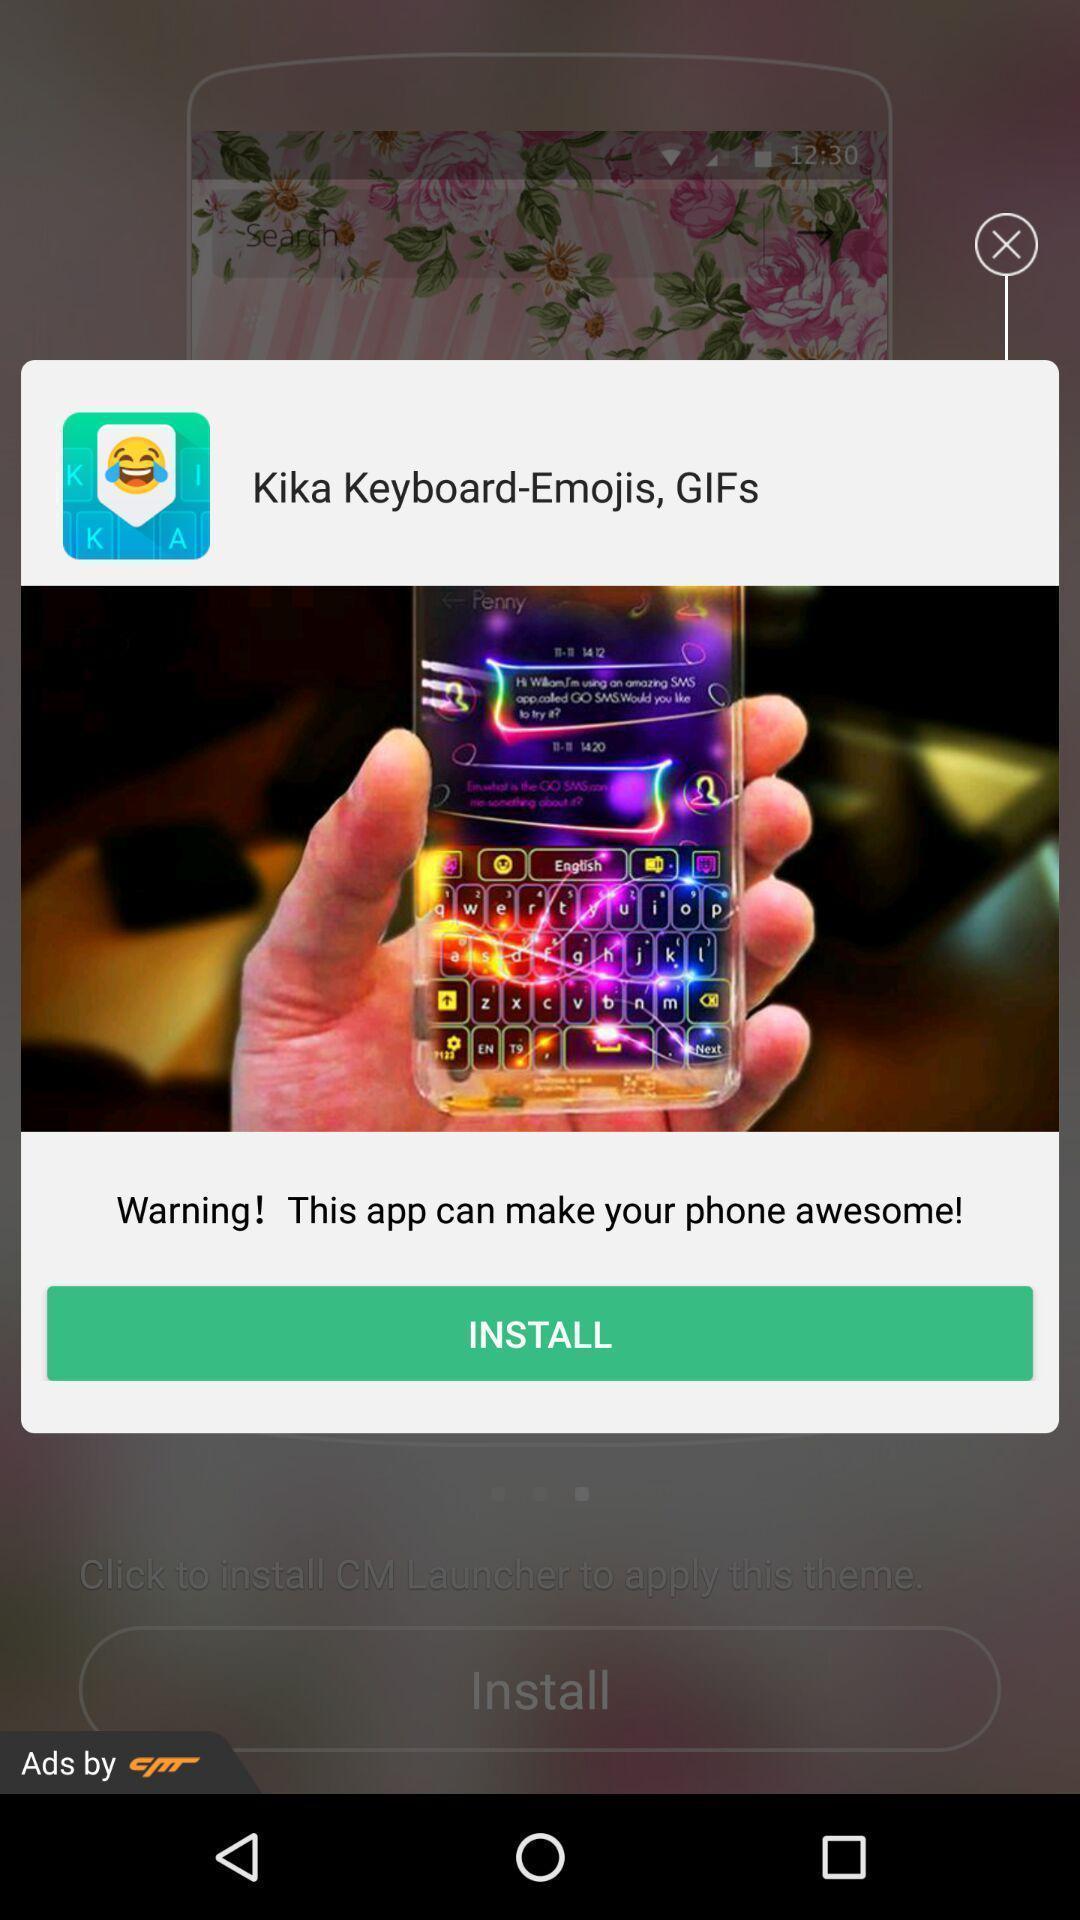Describe this image in words. Pop-up showing recommendation for installing keyboard app. 